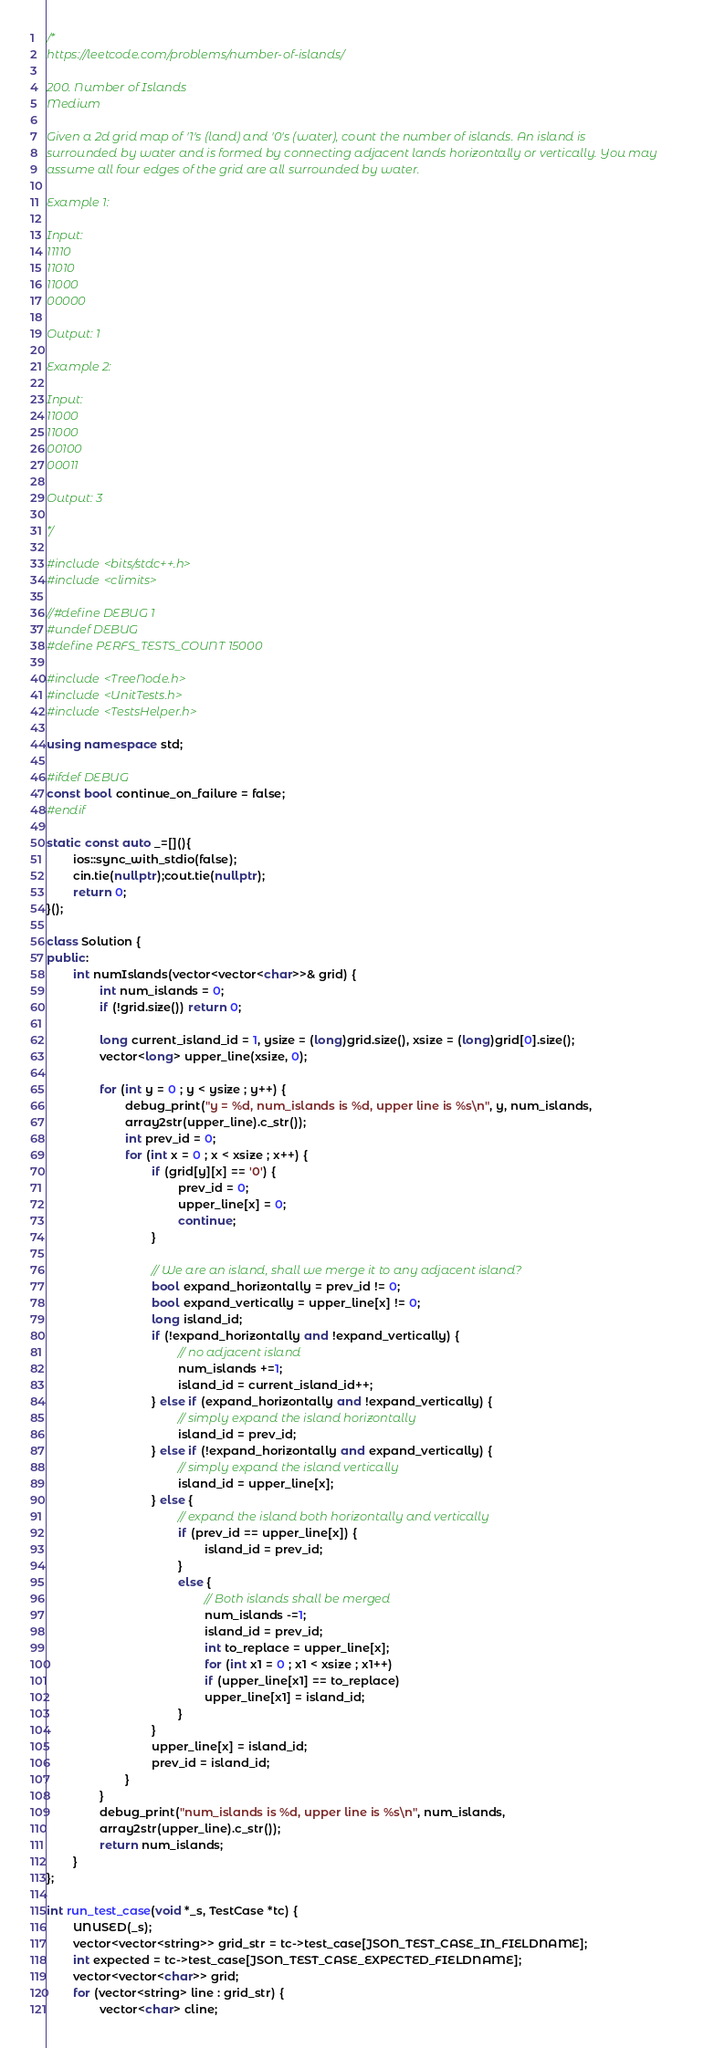Convert code to text. <code><loc_0><loc_0><loc_500><loc_500><_C++_>/*
https://leetcode.com/problems/number-of-islands/

200. Number of Islands
Medium

Given a 2d grid map of '1's (land) and '0's (water), count the number of islands. An island is
surrounded by water and is formed by connecting adjacent lands horizontally or vertically. You may
assume all four edges of the grid are all surrounded by water.

Example 1:

Input:
11110
11010
11000
00000

Output: 1

Example 2:

Input:
11000
11000
00100
00011

Output: 3

*/

#include <bits/stdc++.h>
#include <climits>

//#define DEBUG 1
#undef DEBUG
#define PERFS_TESTS_COUNT 15000

#include <TreeNode.h>
#include <UnitTests.h>
#include <TestsHelper.h>

using namespace std;

#ifdef DEBUG
const bool continue_on_failure = false;
#endif

static const auto _=[](){
        ios::sync_with_stdio(false);
        cin.tie(nullptr);cout.tie(nullptr);
        return 0;
}();

class Solution {
public:
        int numIslands(vector<vector<char>>& grid) {
                int num_islands = 0;
                if (!grid.size()) return 0;

                long current_island_id = 1, ysize = (long)grid.size(), xsize = (long)grid[0].size();
                vector<long> upper_line(xsize, 0);

                for (int y = 0 ; y < ysize ; y++) {
                        debug_print("y = %d, num_islands is %d, upper line is %s\n", y, num_islands,
                        array2str(upper_line).c_str());
                        int prev_id = 0;
                        for (int x = 0 ; x < xsize ; x++) {
                                if (grid[y][x] == '0') {
                                        prev_id = 0;
                                        upper_line[x] = 0;
                                        continue;
                                }

                                // We are an island, shall we merge it to any adjacent island?
                                bool expand_horizontally = prev_id != 0;
                                bool expand_vertically = upper_line[x] != 0;
                                long island_id;
                                if (!expand_horizontally and !expand_vertically) {
                                        // no adjacent island
                                        num_islands +=1;
                                        island_id = current_island_id++;
                                } else if (expand_horizontally and !expand_vertically) {
                                        // simply expand the island horizontally
                                        island_id = prev_id;
                                } else if (!expand_horizontally and expand_vertically) {
                                        // simply expand the island vertically
                                        island_id = upper_line[x];
                                } else {
                                        // expand the island both horizontally and vertically
                                        if (prev_id == upper_line[x]) {
                                                island_id = prev_id;
                                        }
                                        else {
                                                // Both islands shall be merged
                                                num_islands -=1;
                                                island_id = prev_id;
                                                int to_replace = upper_line[x];
                                                for (int x1 = 0 ; x1 < xsize ; x1++)
                                                if (upper_line[x1] == to_replace)
                                                upper_line[x1] = island_id;
                                        }
                                }
                                upper_line[x] = island_id;
                                prev_id = island_id;
                        }
                }
                debug_print("num_islands is %d, upper line is %s\n", num_islands,
                array2str(upper_line).c_str());
                return num_islands;
        }
};

int run_test_case(void *_s, TestCase *tc) {
        UNUSED(_s);
        vector<vector<string>> grid_str = tc->test_case[JSON_TEST_CASE_IN_FIELDNAME];
        int expected = tc->test_case[JSON_TEST_CASE_EXPECTED_FIELDNAME];
        vector<vector<char>> grid;
        for (vector<string> line : grid_str) {
                vector<char> cline;</code> 